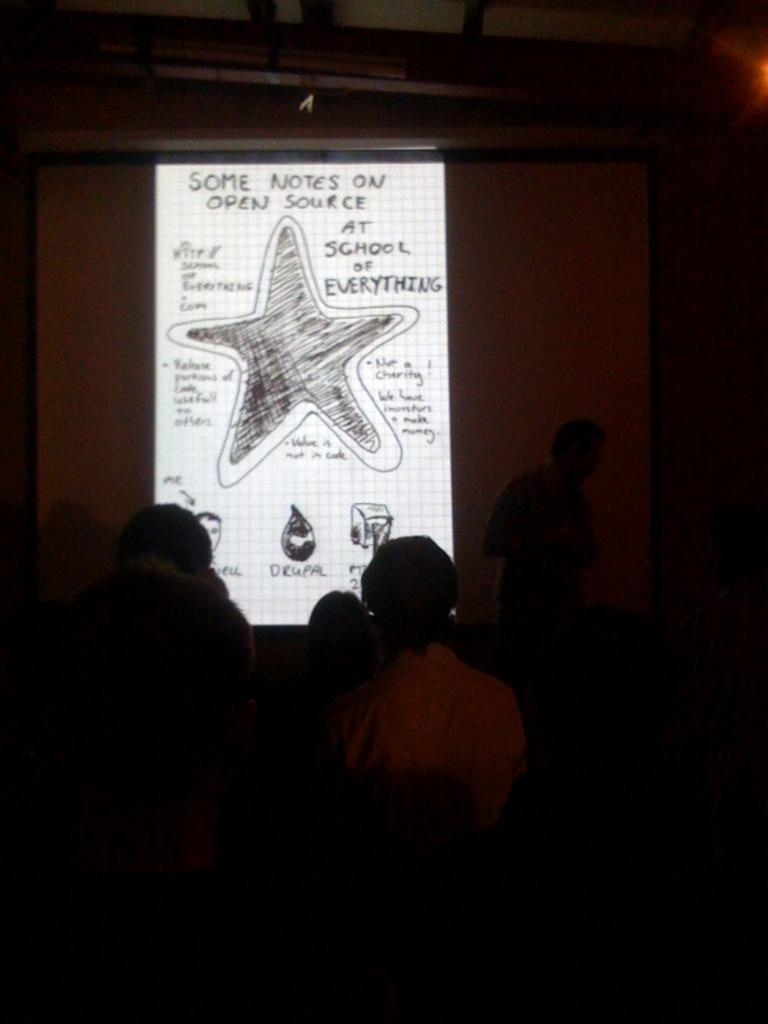Who or what can be seen in the image? There are people in the image. What is the lighting condition in the image? The people are in a dark environment. What is located in the background of the image? There is a screen in the background of the image. What is displayed on the screen? Text is visible on the screen. What color is the shirt worn by the person on the left in the image? There is no shirt visible in the image, as the people are in a dark environment and their clothing is not discernible. 